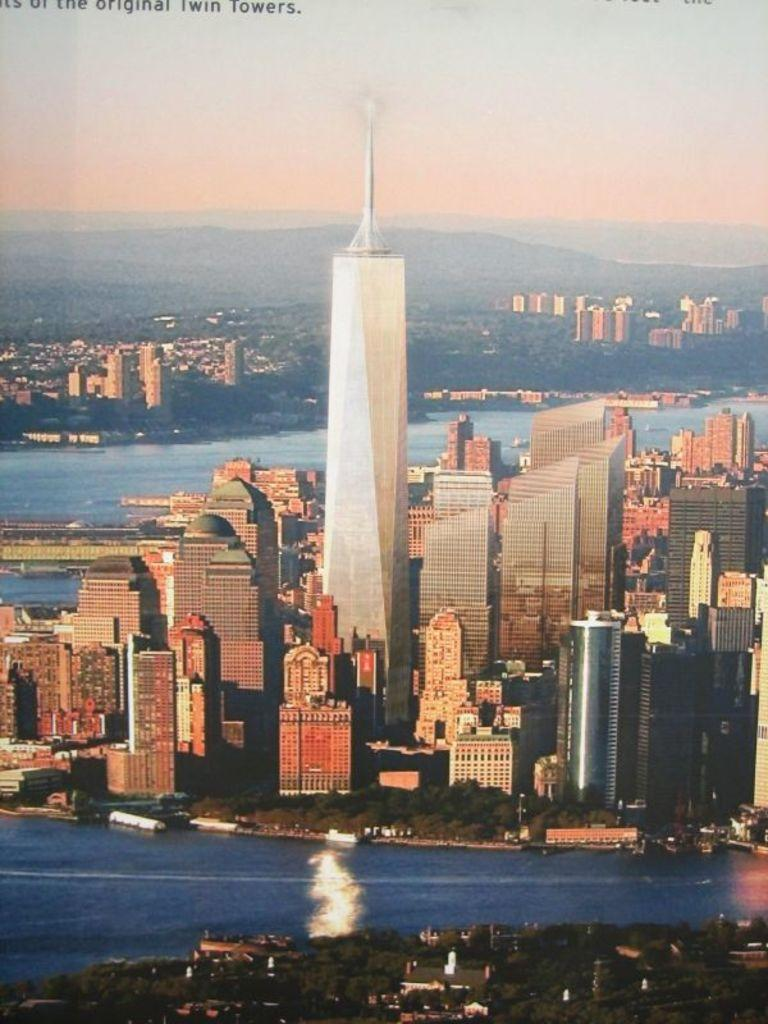What type of structures can be seen in the image? There are buildings in the image. What is surrounding the buildings? Water is visible around the buildings. What is visible at the top of the image? The sky is visible at the top of the image. What is written or displayed in the image? Text is visible in the image. Is there an oven visible in the image? No, there is no oven present in the image. What fact can be learned about the buildings from the image? The provided facts do not include any specific information about the buildings that could be considered a fact. 